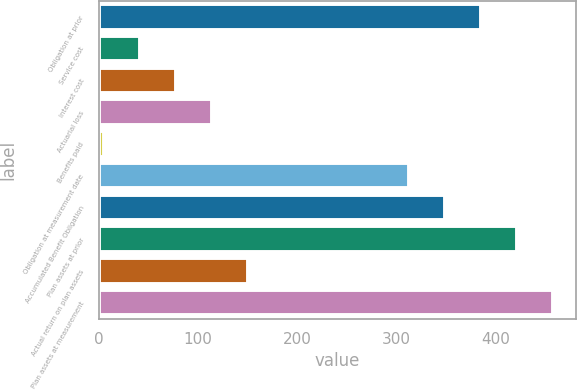Convert chart to OTSL. <chart><loc_0><loc_0><loc_500><loc_500><bar_chart><fcel>Obligation at prior<fcel>Service cost<fcel>Interest cost<fcel>Actuarial loss<fcel>Benefits paid<fcel>Obligation at measurement date<fcel>Accumulated Benefit Obligation<fcel>Plan assets at prior<fcel>Actual return on plan assets<fcel>Plan assets at measurement<nl><fcel>385.6<fcel>41.3<fcel>77.6<fcel>113.9<fcel>5<fcel>313<fcel>349.3<fcel>421.9<fcel>150.2<fcel>458.2<nl></chart> 